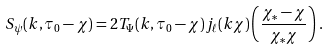Convert formula to latex. <formula><loc_0><loc_0><loc_500><loc_500>S _ { \psi } ( k , \tau _ { 0 } - \chi ) = 2 T _ { \Psi } ( k , \tau _ { 0 } - \chi ) j _ { \ell } ( k \chi ) \left ( \frac { \chi _ { * } - \chi } { \chi _ { * } \chi } \right ) \, .</formula> 